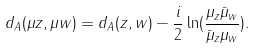<formula> <loc_0><loc_0><loc_500><loc_500>d _ { A } ( \mu z , \mu w ) = d _ { A } ( z , w ) - \frac { i } { 2 } \ln ( \frac { \mu _ { z } \bar { \mu } _ { w } } { \bar { \mu } _ { z } \mu _ { w } } ) .</formula> 